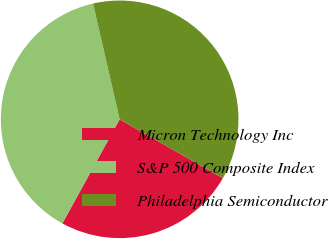Convert chart to OTSL. <chart><loc_0><loc_0><loc_500><loc_500><pie_chart><fcel>Micron Technology Inc<fcel>S&P 500 Composite Index<fcel>Philadelphia Semiconductor<nl><fcel>24.77%<fcel>38.39%<fcel>36.84%<nl></chart> 